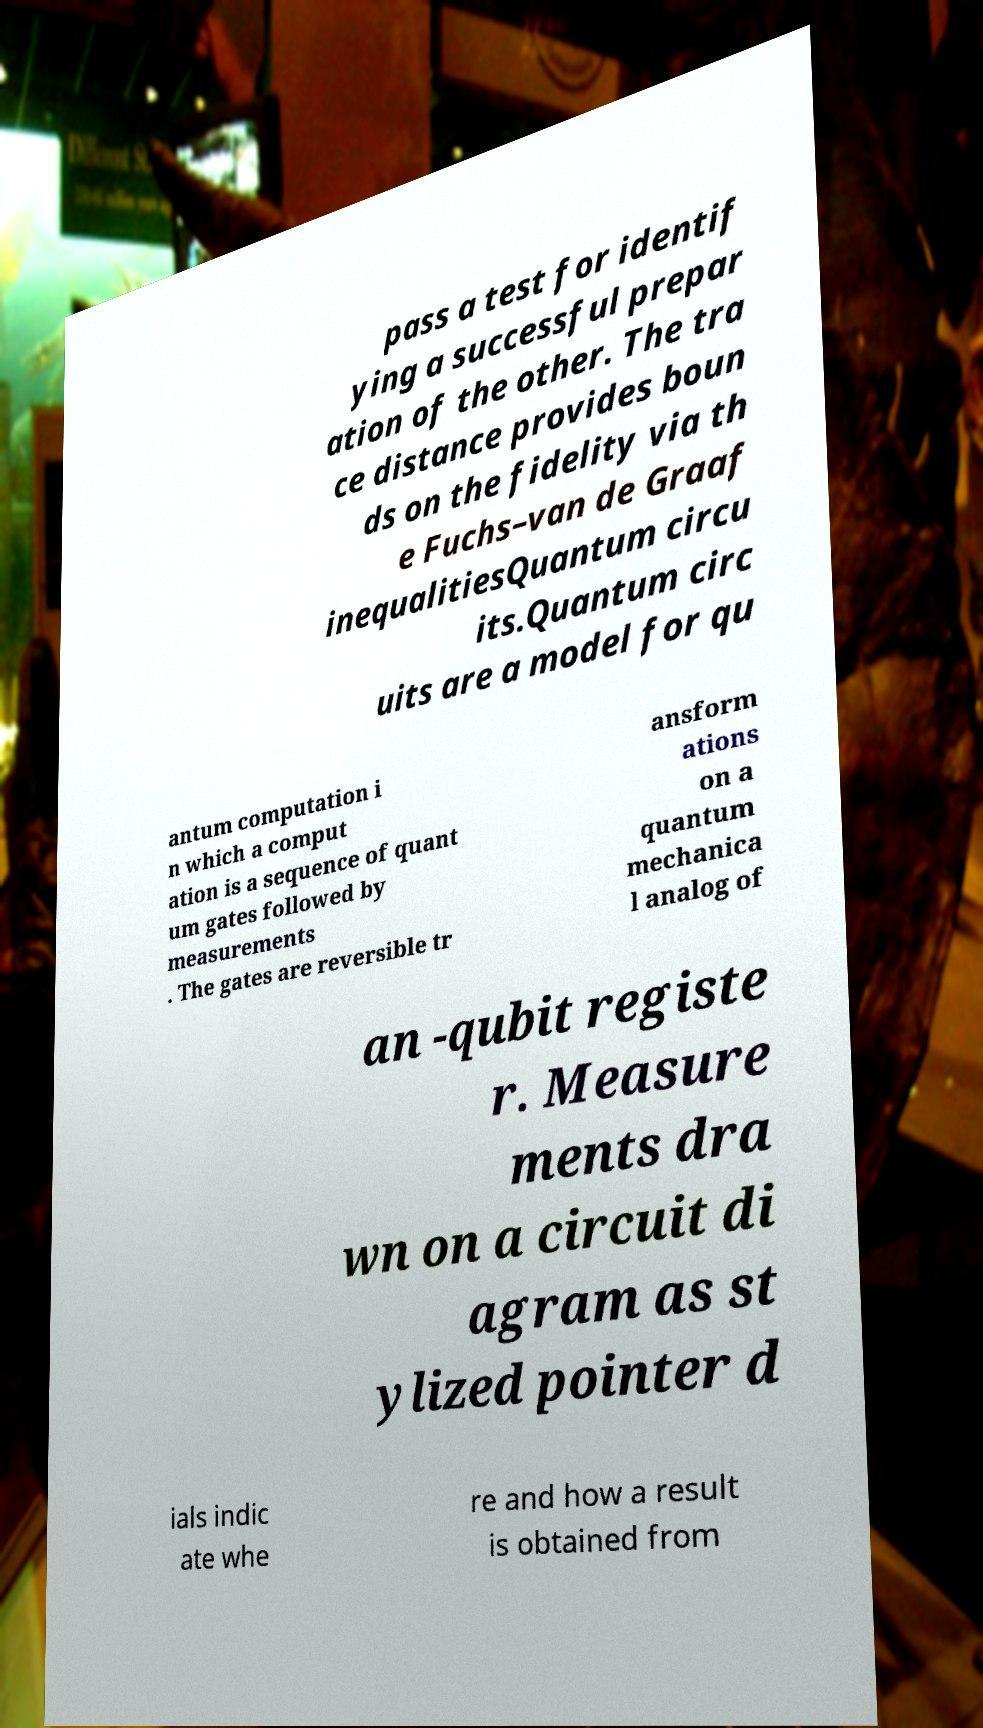Please read and relay the text visible in this image. What does it say? pass a test for identif ying a successful prepar ation of the other. The tra ce distance provides boun ds on the fidelity via th e Fuchs–van de Graaf inequalitiesQuantum circu its.Quantum circ uits are a model for qu antum computation i n which a comput ation is a sequence of quant um gates followed by measurements . The gates are reversible tr ansform ations on a quantum mechanica l analog of an -qubit registe r. Measure ments dra wn on a circuit di agram as st ylized pointer d ials indic ate whe re and how a result is obtained from 